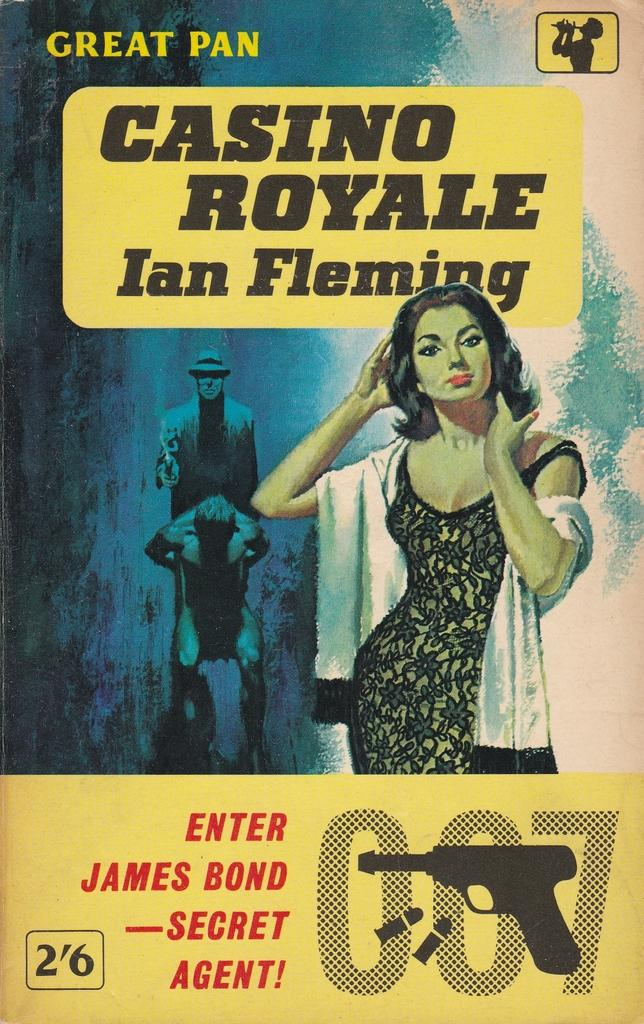What is featured on the poster in the image? The poster contains a picture of a woman and two persons. What objects are depicted on the poster? There is a gun and bullets shown on the poster. What else can be found on the poster? Text is written on the poster. Where is the pencil located in the image? There is no pencil present in the image. What type of furniture can be seen in the bedroom in the image? There is no bedroom present in the image; it features a poster with various elements. 